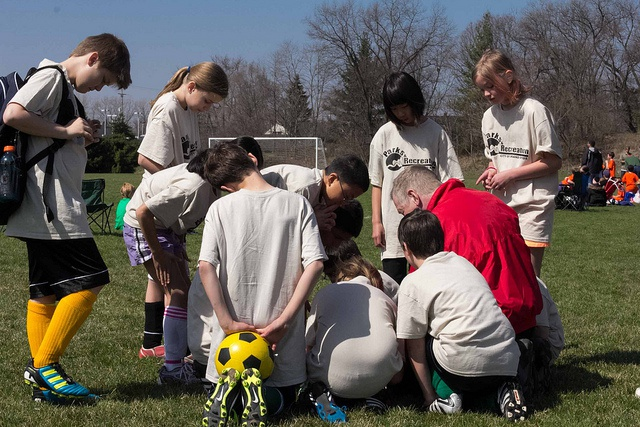Describe the objects in this image and their specific colors. I can see people in gray, lightgray, black, and darkgray tones, people in gray, black, orange, and maroon tones, people in gray, black, lightgray, and darkgray tones, people in gray, black, darkgray, and lightgray tones, and people in gray, lightgray, maroon, and black tones in this image. 